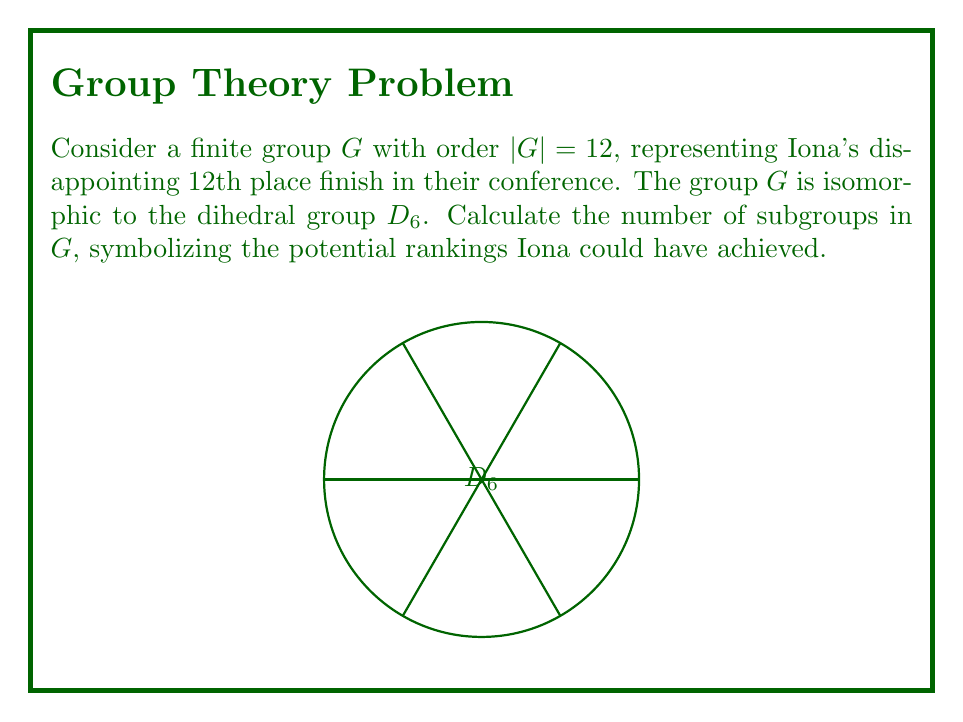Give your solution to this math problem. To find the number of subgroups in $G \cong D_6$, we follow these steps:

1) First, recall the subgroup structure of $D_6$:
   - One subgroup of order 12 (the whole group)
   - One subgroup of order 1 (the trivial subgroup)
   - One normal subgroup of order 6 (the rotational subgroup)
   - Three subgroups of order 4 (generated by a reflection and a 180° rotation)
   - Four subgroups of order 3 (generated by 120° rotations)
   - Six subgroups of order 2 (generated by reflections)

2) To count the total number of subgroups:
   $$1 + 1 + 1 + 3 + 4 + 6 = 16$$

3) This result can be verified using the subgroup lattice of $D_6$, which forms a partially ordered set with 16 elements.

4) The number 16 symbolizes the 16 possible rankings Iona could have theoretically achieved in their conference, from 1st place (the whole group) to 12th place (the trivial subgroup), with various intermediate possibilities represented by the other subgroups.
Answer: 16 subgroups 